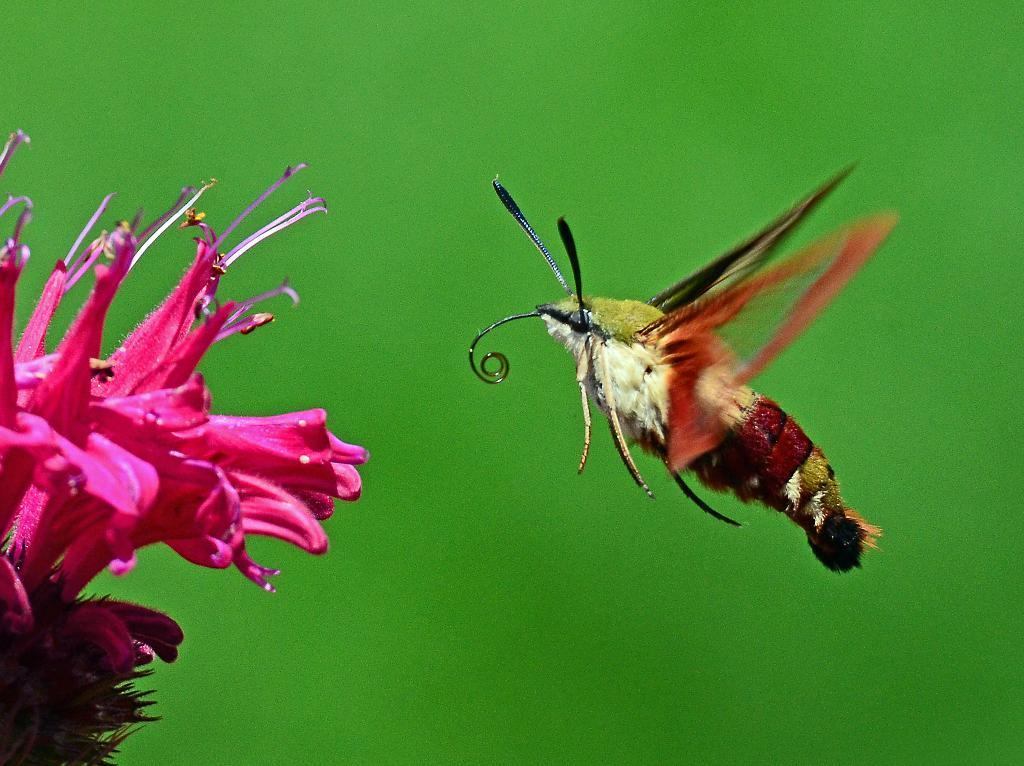What is the main subject of the image? There is a bunch of flowers in the image. Are there any other living organisms present in the image? Yes, there is an insect in the image. What color is predominant in the background of the image? The background of the image is green. What type of mint can be seen growing near the flowers in the image? There is no mint present in the image; it only features a bunch of flowers and an insect. Is there a birthday celebration happening in the image? There is no indication of a birthday celebration in the image. 